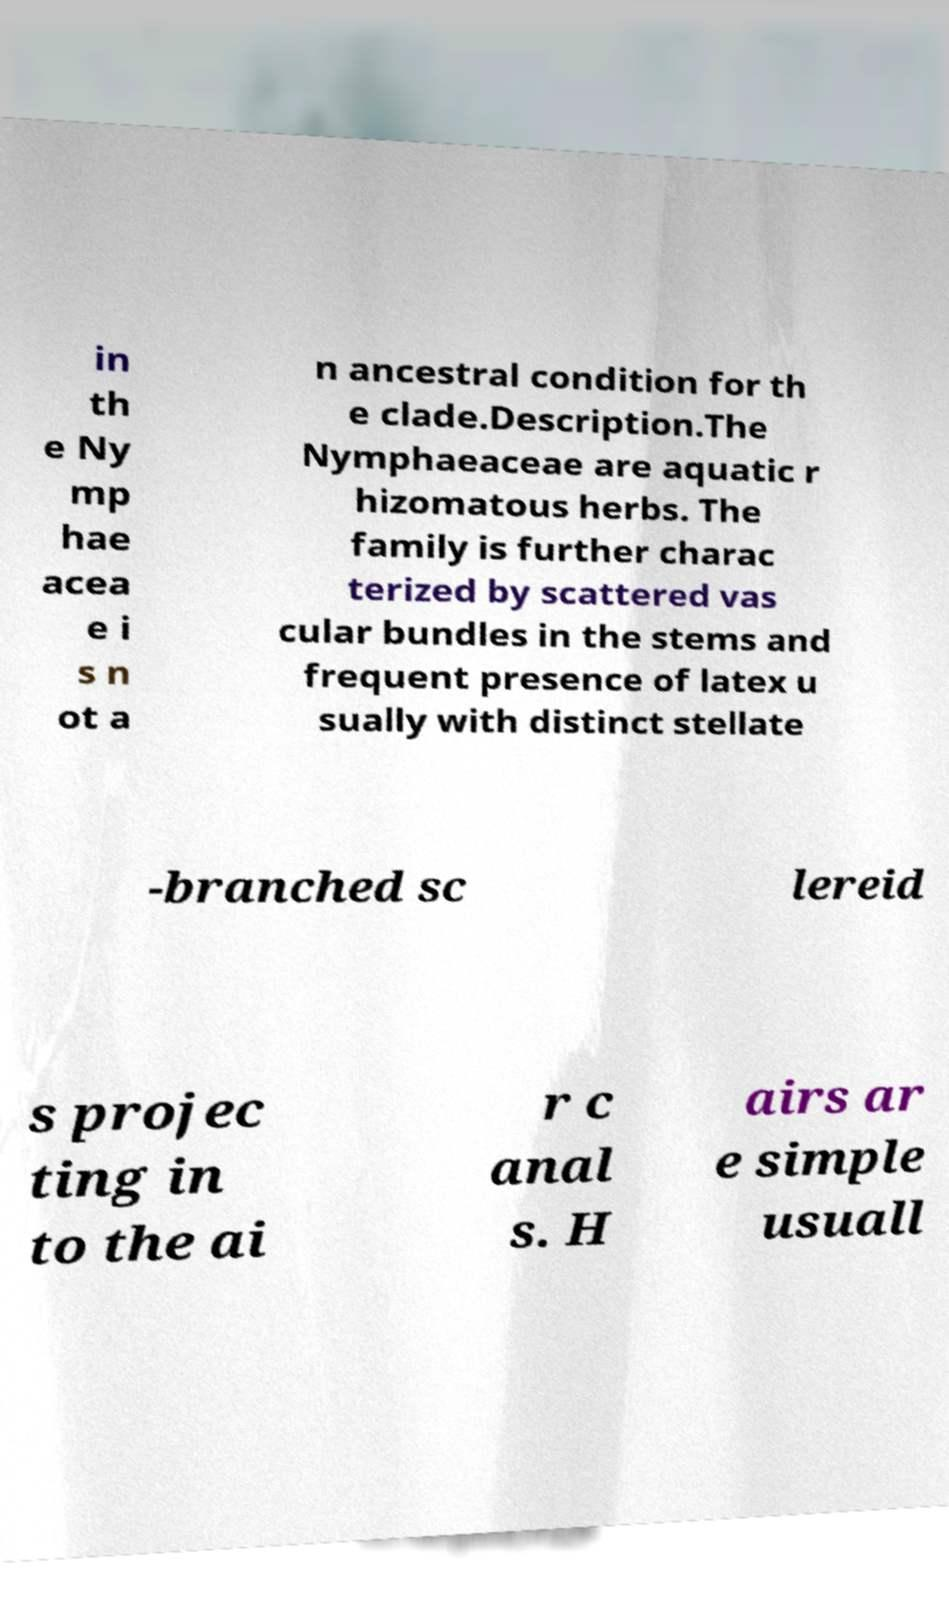Could you assist in decoding the text presented in this image and type it out clearly? in th e Ny mp hae acea e i s n ot a n ancestral condition for th e clade.Description.The Nymphaeaceae are aquatic r hizomatous herbs. The family is further charac terized by scattered vas cular bundles in the stems and frequent presence of latex u sually with distinct stellate -branched sc lereid s projec ting in to the ai r c anal s. H airs ar e simple usuall 